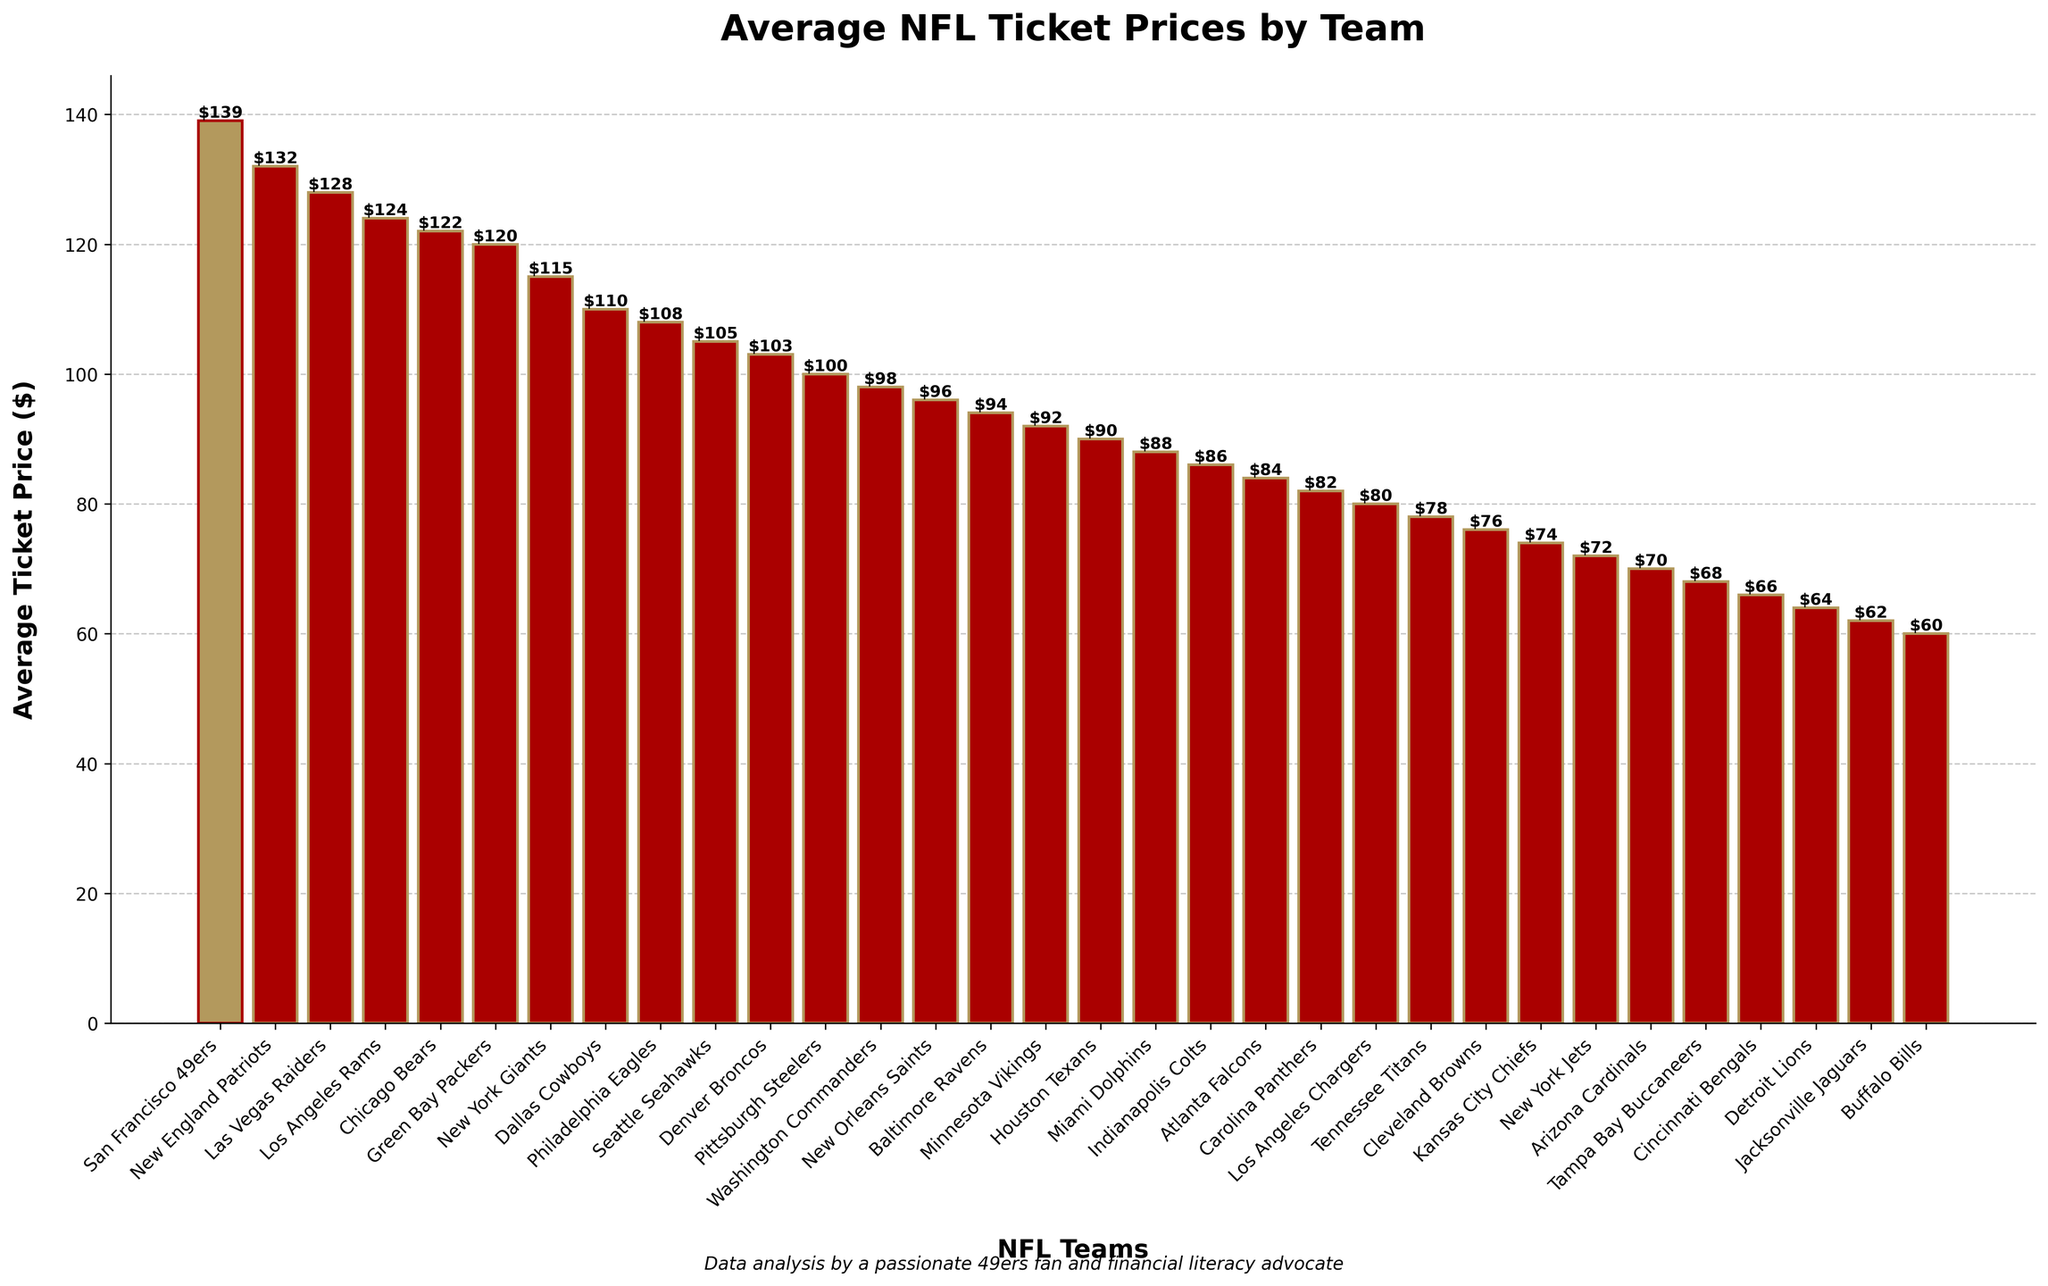which team has the highest average ticket price? The highest bar in the bar chart represents the San Francisco 49ers, with ticket prices of $139.
Answer: San Francisco 49ers Which team has the lowest average ticket price? The shortest bar represents the Buffalo Bills, with an average ticket price of $60.
Answer: Buffalo Bills What is the difference in average ticket price between the San Francisco 49ers and the Buffalo Bills? The 49ers' ticket price is $139, and the Bills' ticket price is $60. The difference is $139 - $60.
Answer: $79 How many teams have an average ticket price above $100? Count the number of bars that show ticket prices above the $100 mark: There are 10 such bars.
Answer: 10 What's the combined average ticket price of teams with ticket prices exactly equal to $120? The only team with a ticket price of $120 is the Green Bay Packers. Sum = 120.
Answer: 120 Are there more teams with average ticket prices above $100 or below $100? Count the number of bars above $100 (10) and below $100 (22). Compare the counts.
Answer: Below $100 What is the range of average ticket prices shown in the chart? The range is the difference between the highest and lowest prices: $139 (49ers) - $60 (Bills).
Answer: $79 Which team has an average ticket price closest to the league median? List the ticket prices in order, find the median value, and identify the team. Prices: 60, 62, 64, 66, 68, 70, 72, 74, 76, 78, 80, 82, 84, 86, 88, 90, 92, 94, 96, 98, 100, 103, 105, 108, 110, 115, 120, 122, 124, 128, 132, 139. Median is 92. The Minnesota Vikings have a ticket price of 92.
Answer: Minnesota Vikings Which team has a ticket price that is visually highlighted differently from the others? The plot highlights the San Francisco 49ers' bar differently by coloring them differently.
Answer: San Francisco 49ers How many teams have an average ticket price that is less than the San Francisco 49ers? Count the number of bars shorter than the 49ers' bar with a height of $139. There are 31 teams below.
Answer: 31 What is the average ticket price of the top 3 most expensive teams? Sum of the top three ticket prices: $139 (49ers), $132 (Patriots), $128 (Raiders). Calculate the average: ($139 + $132 + $128) / 3.
Answer: $133 